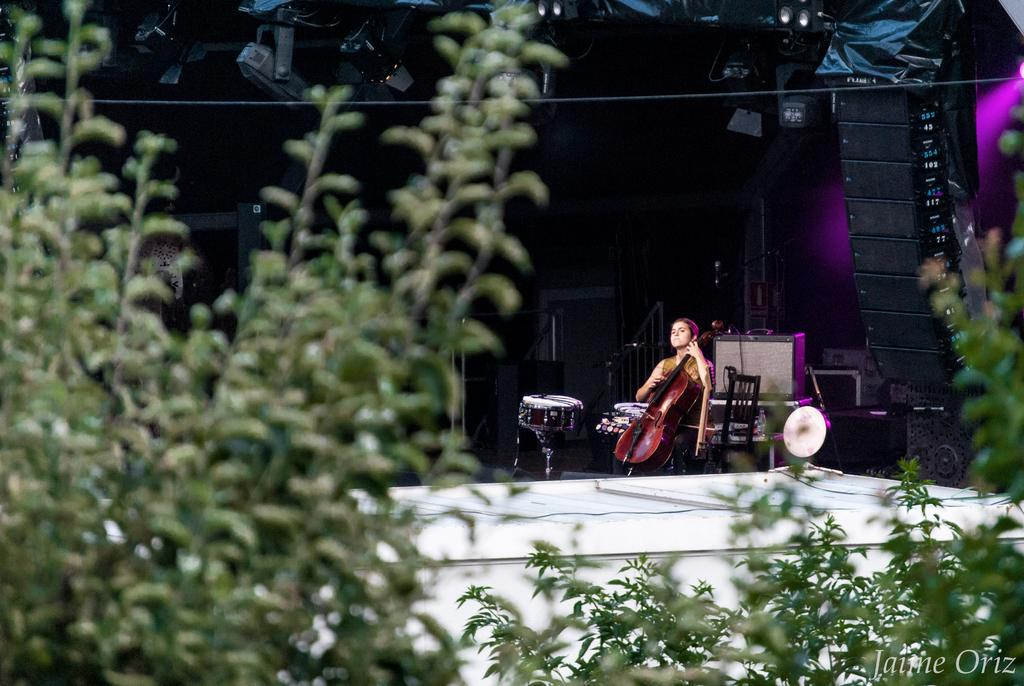What type of plants can be seen in the image? There are green plants in the image. What is the person in the image doing? The person is playing a musical instrument in the image. Can you describe any other objects visible in the image? Yes, there are objects visible in the image. What type of lighting is present in the image? There are lights in the image. What is the surface visible in the image? The ground is visible in the image. What class is the person attending in the image? There is no indication of a class or any educational setting in the image. What is the person's interest in the image? The image does not provide information about the person's interests. 